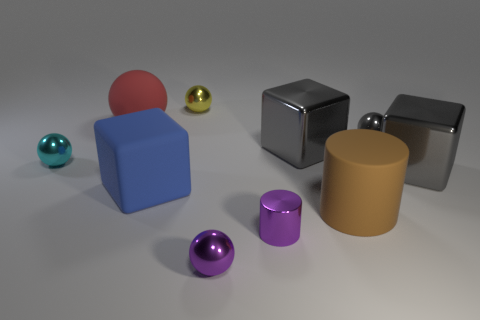Subtract all green spheres. How many gray cubes are left? 2 Subtract all red balls. How many balls are left? 4 Subtract 2 spheres. How many spheres are left? 3 Subtract all purple balls. How many balls are left? 4 Subtract all green spheres. Subtract all gray cylinders. How many spheres are left? 5 Subtract 1 purple cylinders. How many objects are left? 9 Subtract all cylinders. How many objects are left? 8 Subtract all big brown matte blocks. Subtract all purple shiny balls. How many objects are left? 9 Add 3 tiny cyan metal objects. How many tiny cyan metal objects are left? 4 Add 5 tiny rubber blocks. How many tiny rubber blocks exist? 5 